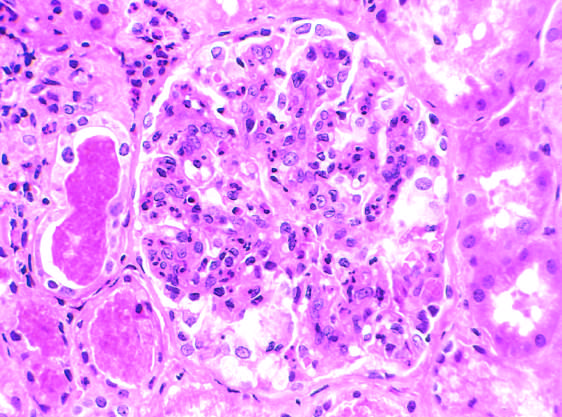where are the red blood cell casts?
Answer the question using a single word or phrase. In the tubules 